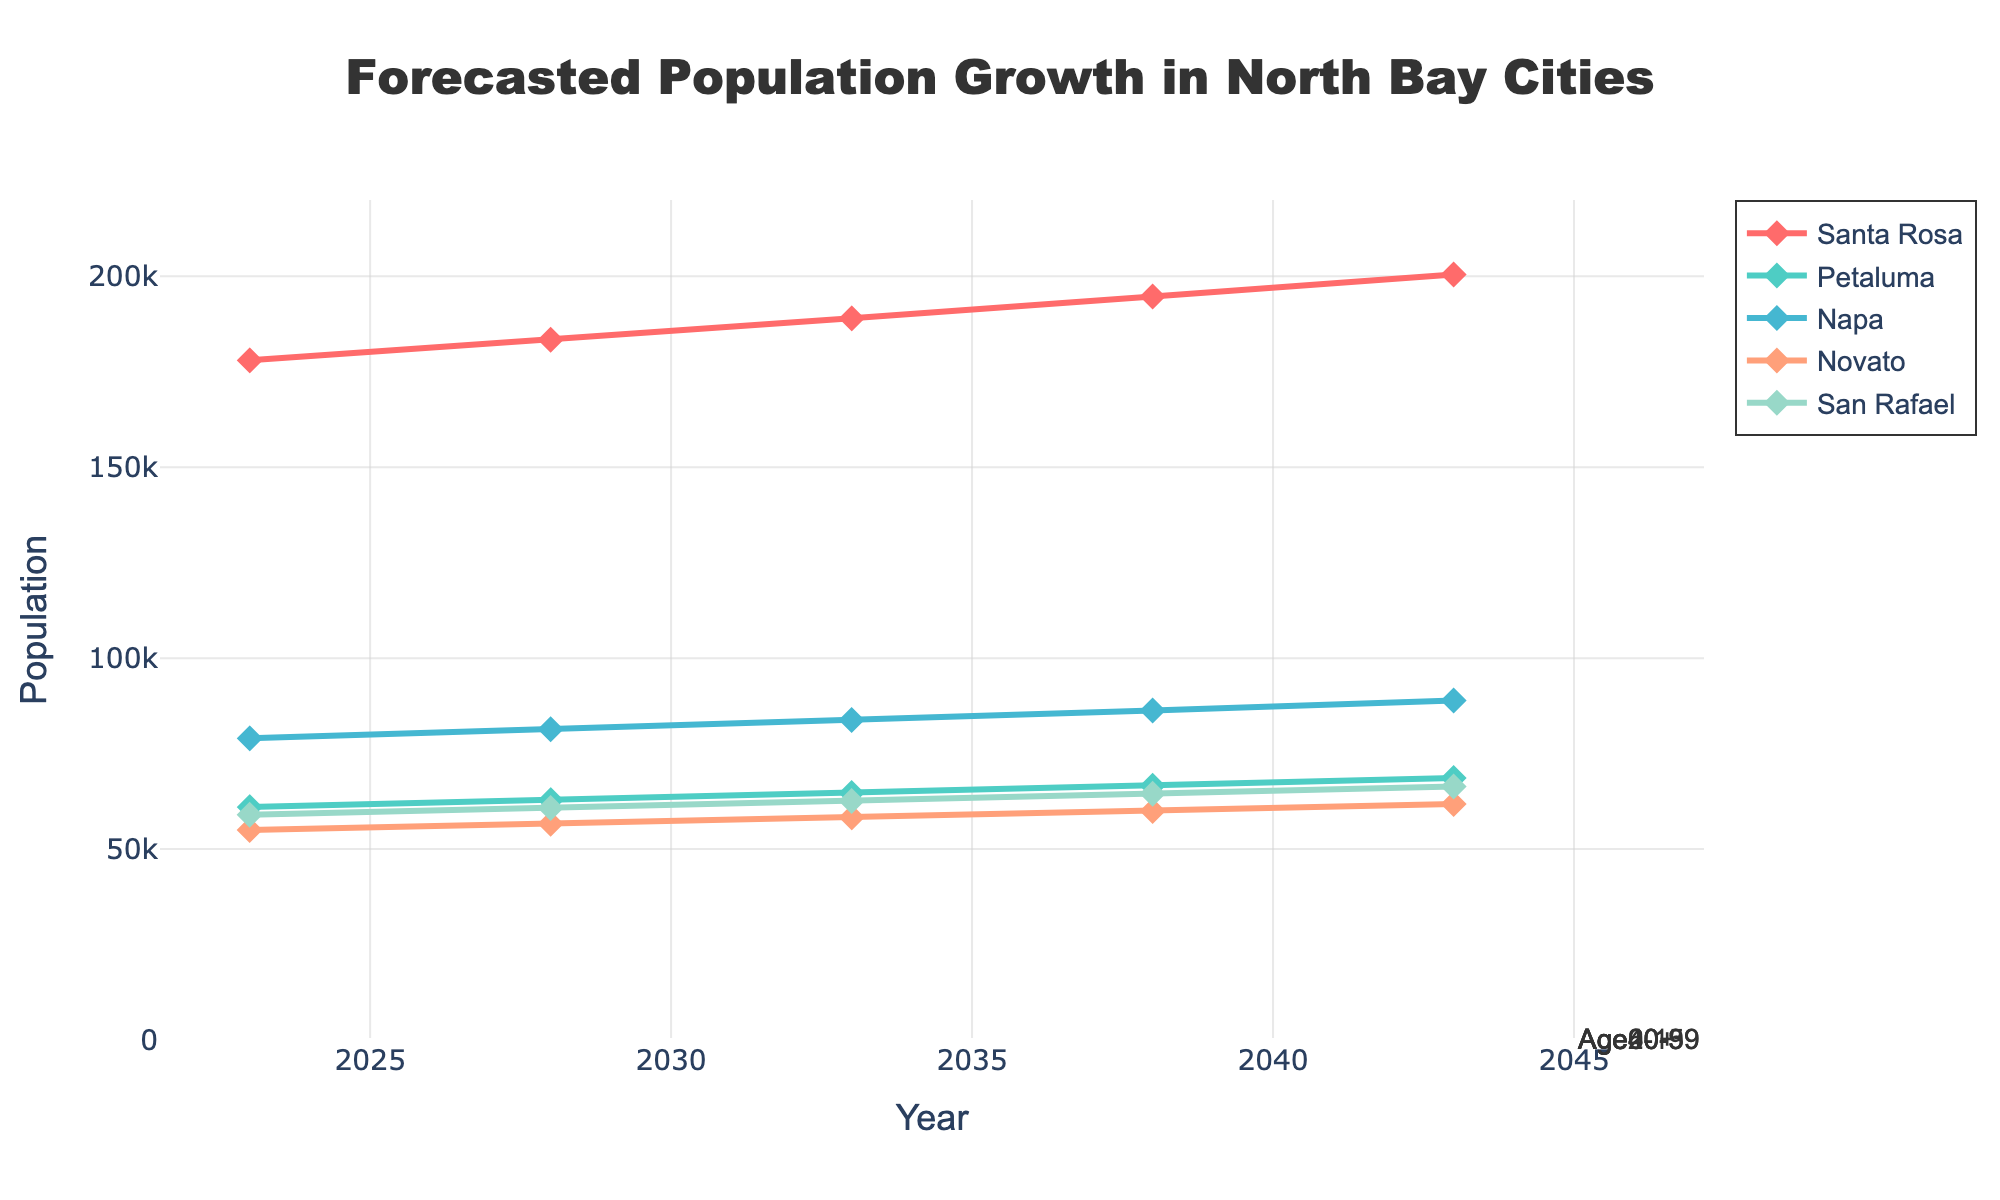What is the title of the chart? The title of the chart is written at the top and clearly states its purpose.
Answer: Forecasted Population Growth in North Bay Cities How does the population of Santa Rosa change from 2023 to 2043? The population numbers for Santa Rosa can be read directly from the Y-axis values corresponding to the years 2023 and 2043.
Answer: It increases from 178,000 to 200,500 Which city has the lowest population in 2043? By comparing the Y-axis values of all cities in 2043, the city with the lowest population can be identified.
Answer: Novato What percentage of the population is aged 60+ in 2043? By referring to the annotations on the fan chart, the percentage of the age group 60+ can be identified in the year 2043.
Answer: 34% How does the age group distribution for Age20-39 change from 2023 to 2043? By comparing the percentage values for the Age20-39 group in 2023 and 2043, we see the change over time.
Answer: It decreases from 27% to 23% Which city shows the highest population growth from 2023 to 2043? By calculating the difference in population for each city between 2023 and 2043 and comparing the results, the city with the highest growth can be identified.
Answer: Santa Rosa (22,500 increase) How does the total percentage of people aged 40 and older change from 2023 to 2043? By summing up the percentages of Age40-59 and Age60+ for 2023 and 2043, we can determine the change.
Answer: It increases from 50% (28% + 22%) to 58% (24% + 34%) Which age group shows the largest increase in percentage from 2023 to 2043? By comparing the percentages of each age group from 2023 to 2043 and identifying the group with the largest positive change, we find the answer.
Answer: Age60+ (22% to 34%) How does the population of Petaluma compare to Napa in 2033? By comparing the population values of Petaluma and Napa in the year 2033 from the chart, their relationship can be determined.
Answer: Petaluma has a smaller population than Napa (64,700 vs. 83,800) 